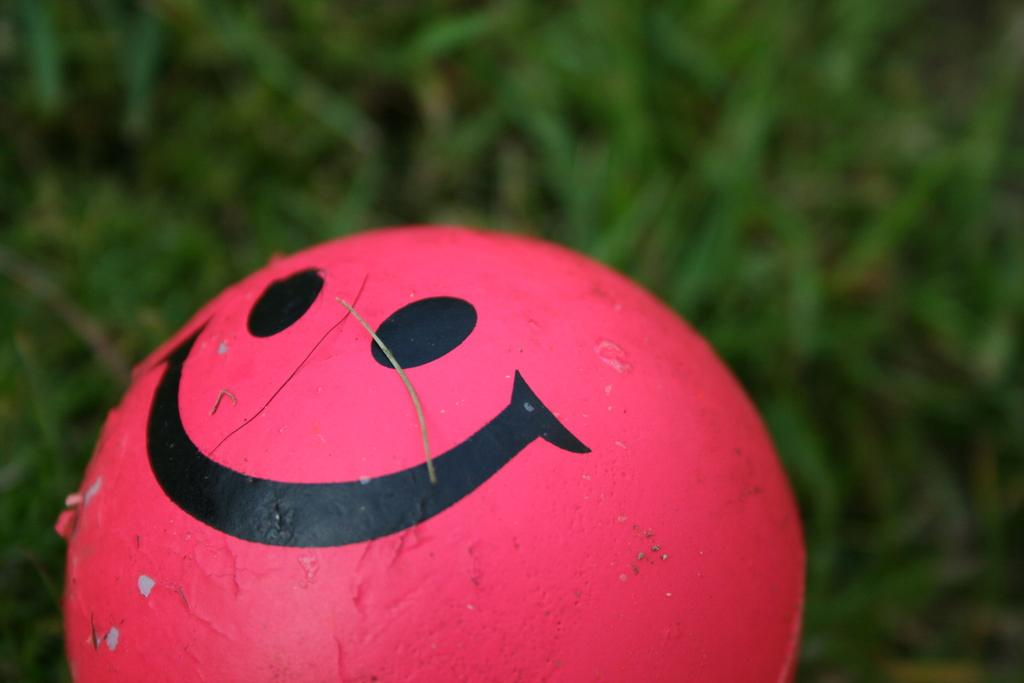What is the main subject in the center of the image? There is a smiley ball in the center of the image. What color is the smiley ball? The smiley ball is red in color. How would you describe the background of the image? The background of the image is blurred. What type of vegetation can be seen in the background? Grass is visible in the background of the image. What type of pear is hanging from the tree in the image? There is no tree or pear present in the image; it features a red smiley ball in the center of the image. Can you see a guitar in the image? No, there is no guitar present in the image. 